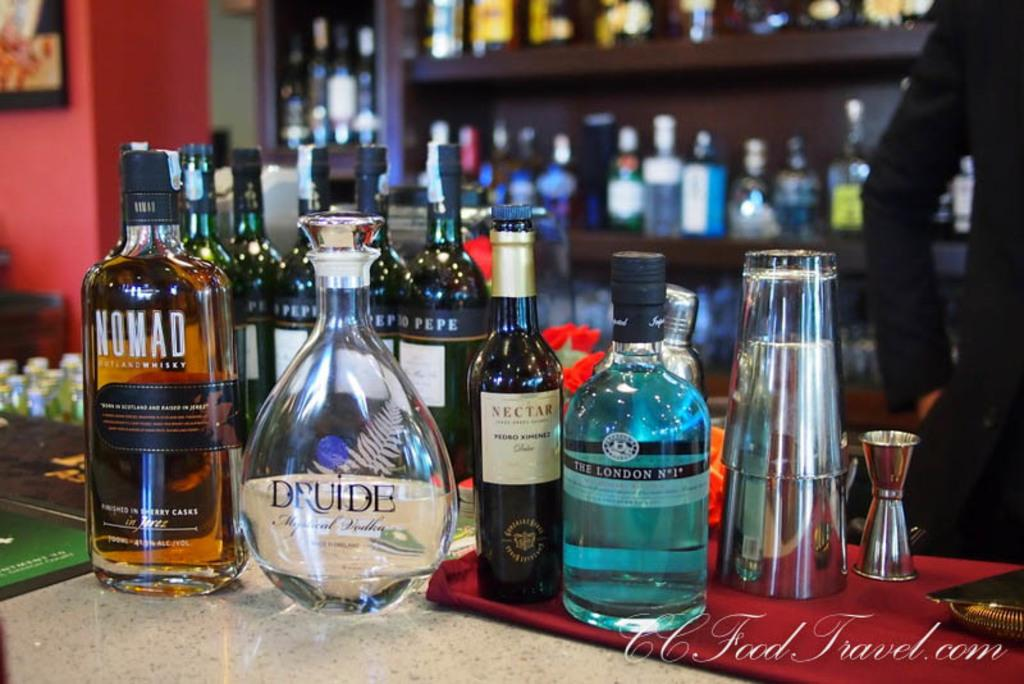<image>
Share a concise interpretation of the image provided. A bar with lots of bottles of liquor including Druide, Nectar, and Nomad whiskey. 